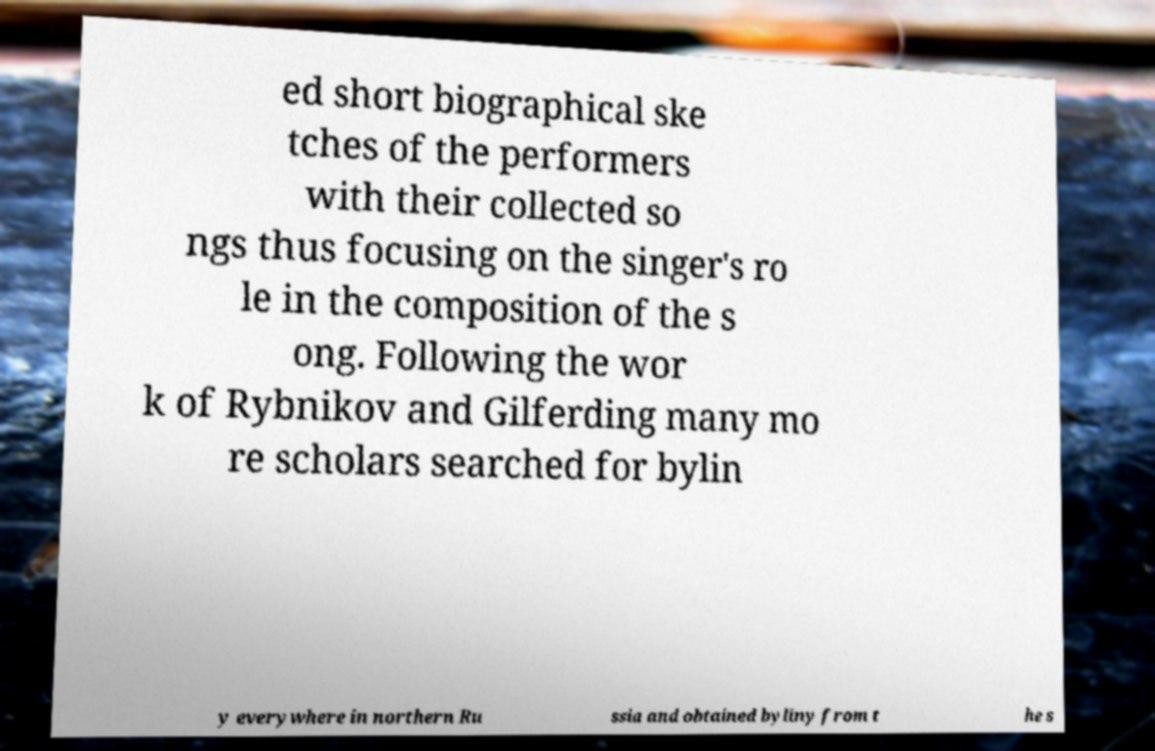Could you extract and type out the text from this image? ed short biographical ske tches of the performers with their collected so ngs thus focusing on the singer's ro le in the composition of the s ong. Following the wor k of Rybnikov and Gilferding many mo re scholars searched for bylin y everywhere in northern Ru ssia and obtained byliny from t he s 